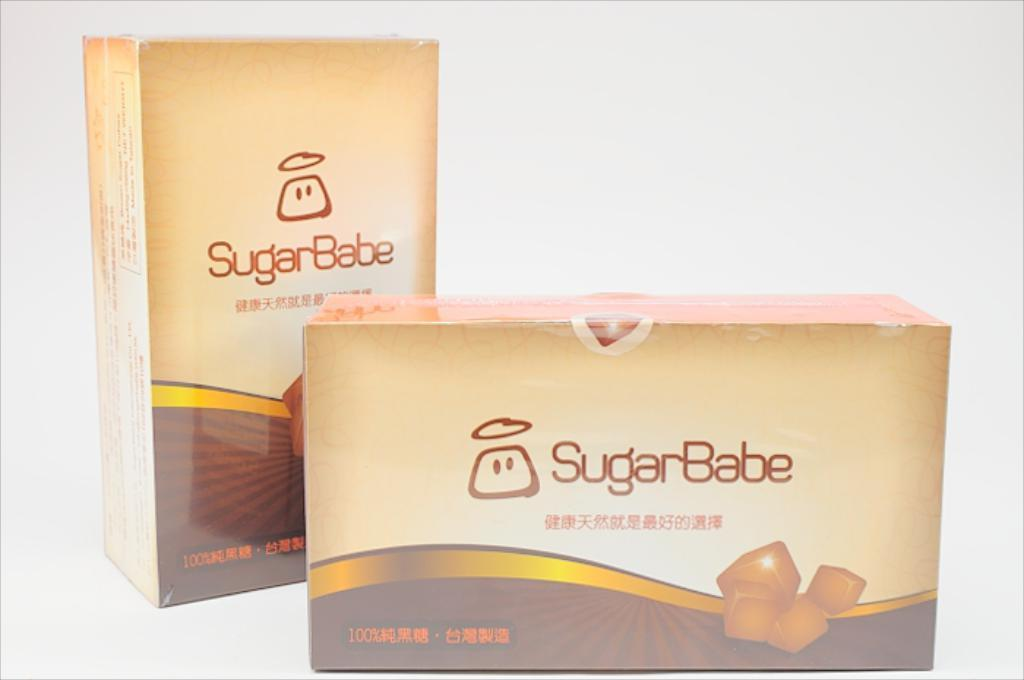<image>
Give a short and clear explanation of the subsequent image. Two boxes of SugarBabe chocolate surrounded by white background. 